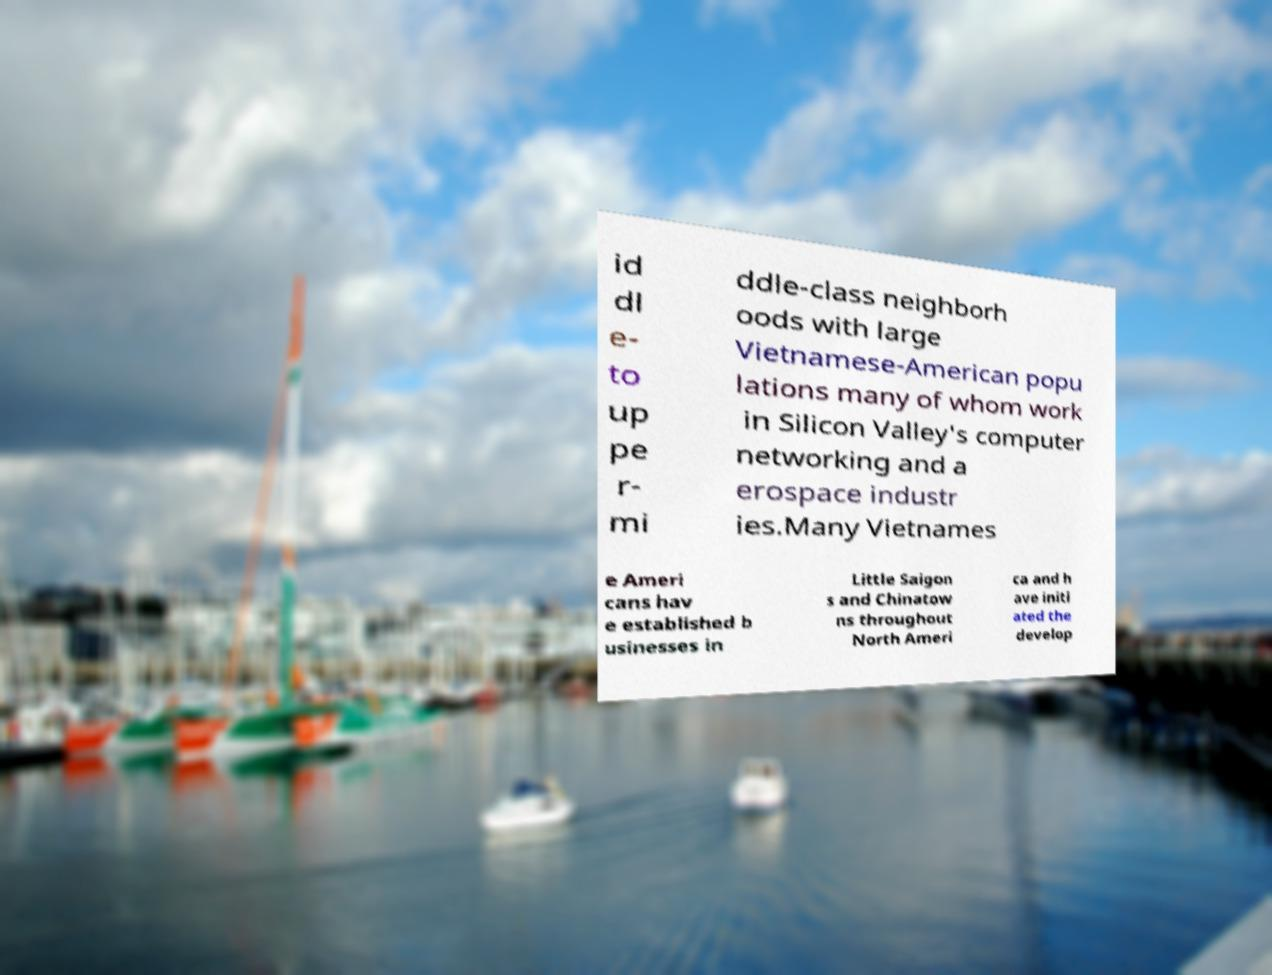Could you extract and type out the text from this image? id dl e- to up pe r- mi ddle-class neighborh oods with large Vietnamese-American popu lations many of whom work in Silicon Valley's computer networking and a erospace industr ies.Many Vietnames e Ameri cans hav e established b usinesses in Little Saigon s and Chinatow ns throughout North Ameri ca and h ave initi ated the develop 